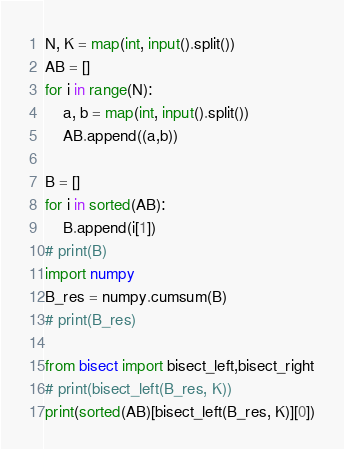<code> <loc_0><loc_0><loc_500><loc_500><_Python_>N, K = map(int, input().split())
AB = []
for i in range(N):
    a, b = map(int, input().split())
    AB.append((a,b))
    
B = []
for i in sorted(AB):
    B.append(i[1])
# print(B)
import numpy
B_res = numpy.cumsum(B)
# print(B_res)

from bisect import bisect_left,bisect_right
# print(bisect_left(B_res, K))
print(sorted(AB)[bisect_left(B_res, K)][0])</code> 